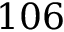<formula> <loc_0><loc_0><loc_500><loc_500>1 0 6</formula> 